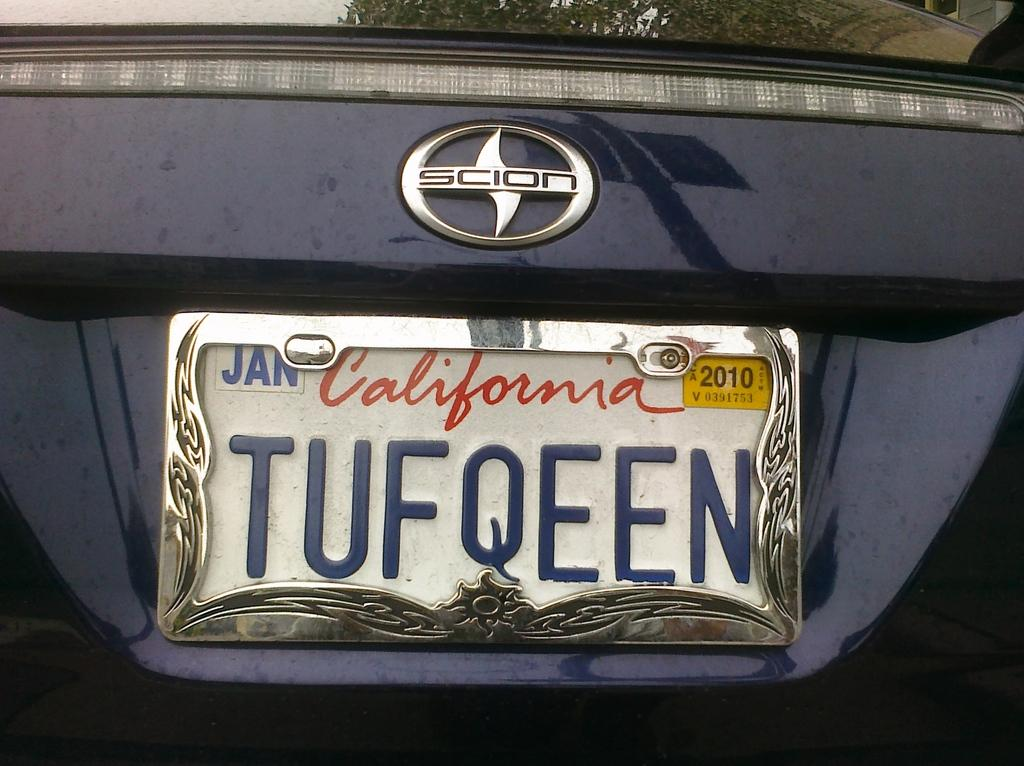Provide a one-sentence caption for the provided image. A California license plate on a Scion expires in 2010. 